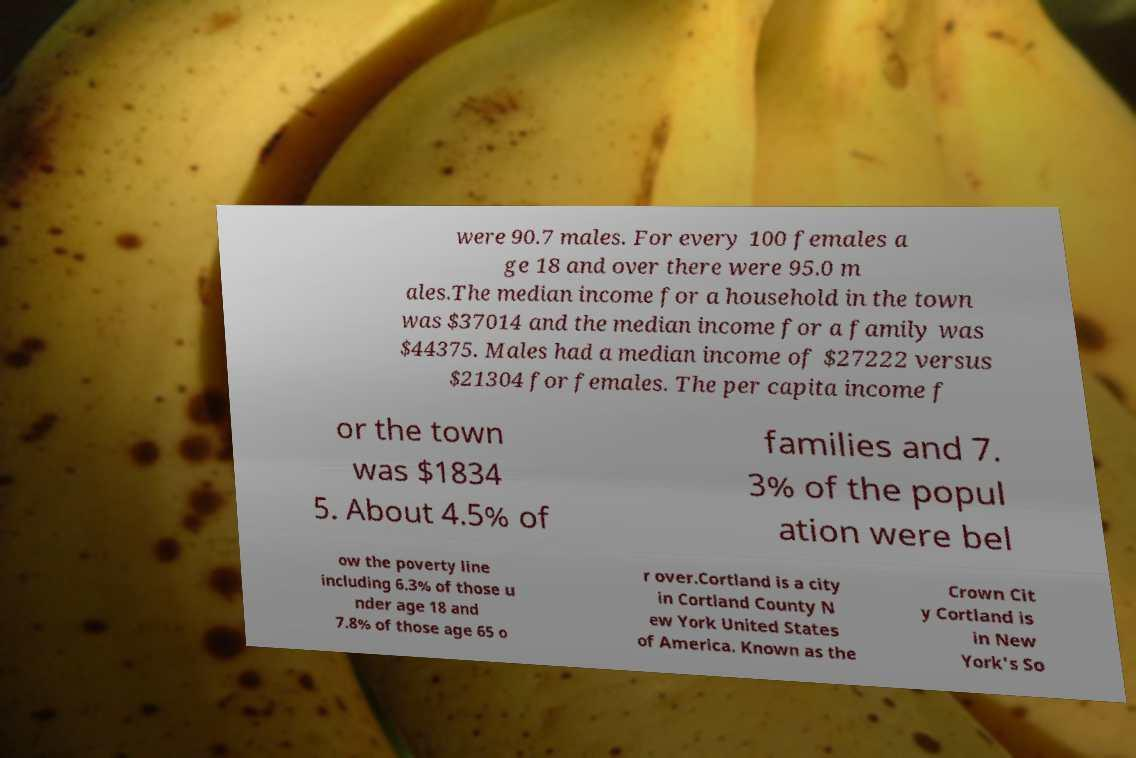Could you assist in decoding the text presented in this image and type it out clearly? were 90.7 males. For every 100 females a ge 18 and over there were 95.0 m ales.The median income for a household in the town was $37014 and the median income for a family was $44375. Males had a median income of $27222 versus $21304 for females. The per capita income f or the town was $1834 5. About 4.5% of families and 7. 3% of the popul ation were bel ow the poverty line including 6.3% of those u nder age 18 and 7.8% of those age 65 o r over.Cortland is a city in Cortland County N ew York United States of America. Known as the Crown Cit y Cortland is in New York's So 